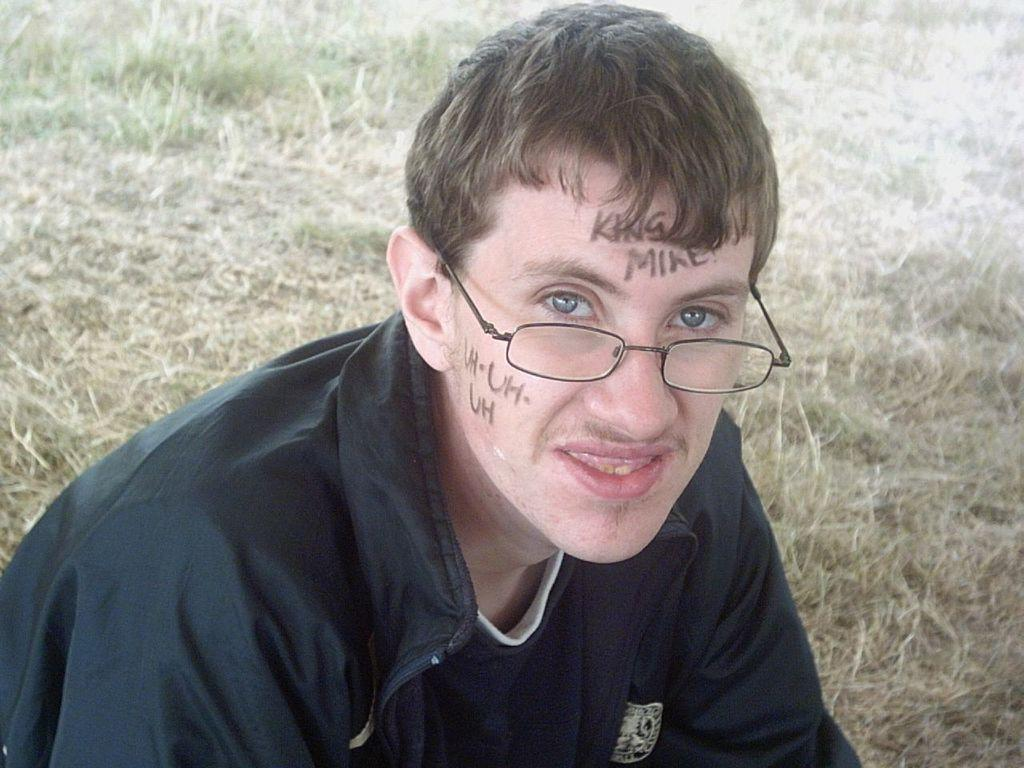What is the main subject of the image? There is a man in the image. What is the man doing in the image? The man is sitting on the grass. What is the man wearing in the image? The man is wearing a black dress. What can be seen on the man's face in the image? There is something written on the man's face. What type of drink is the man holding in the image? There is no drink visible in the image; the man is not holding anything. 